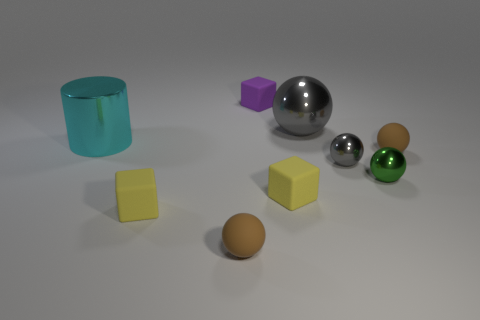Subtract 2 spheres. How many spheres are left? 3 Subtract all green balls. How many balls are left? 4 Subtract all small green metal spheres. How many spheres are left? 4 Subtract all cyan balls. Subtract all purple cylinders. How many balls are left? 5 Add 1 tiny matte cubes. How many objects exist? 10 Subtract all spheres. How many objects are left? 4 Add 3 tiny purple rubber things. How many tiny purple rubber things exist? 4 Subtract 0 red cubes. How many objects are left? 9 Subtract all purple matte cubes. Subtract all big yellow cylinders. How many objects are left? 8 Add 8 tiny purple things. How many tiny purple things are left? 9 